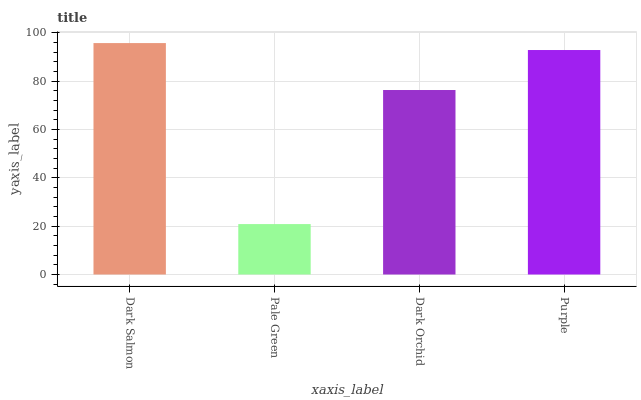Is Dark Orchid the minimum?
Answer yes or no. No. Is Dark Orchid the maximum?
Answer yes or no. No. Is Dark Orchid greater than Pale Green?
Answer yes or no. Yes. Is Pale Green less than Dark Orchid?
Answer yes or no. Yes. Is Pale Green greater than Dark Orchid?
Answer yes or no. No. Is Dark Orchid less than Pale Green?
Answer yes or no. No. Is Purple the high median?
Answer yes or no. Yes. Is Dark Orchid the low median?
Answer yes or no. Yes. Is Dark Salmon the high median?
Answer yes or no. No. Is Dark Salmon the low median?
Answer yes or no. No. 